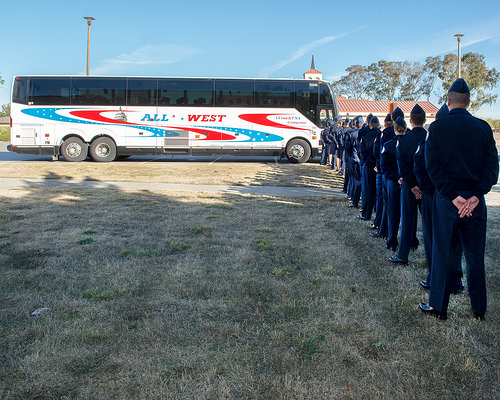<image>
Can you confirm if the bus is behind the person? No. The bus is not behind the person. From this viewpoint, the bus appears to be positioned elsewhere in the scene. Where is the building in relation to the man? Is it above the man? No. The building is not positioned above the man. The vertical arrangement shows a different relationship. 